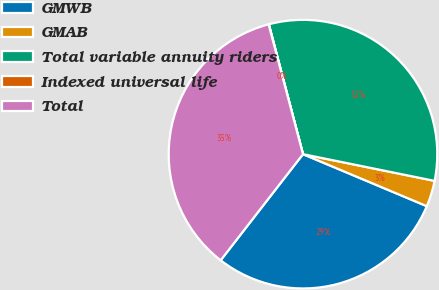Convert chart. <chart><loc_0><loc_0><loc_500><loc_500><pie_chart><fcel>GMWB<fcel>GMAB<fcel>Total variable annuity riders<fcel>Indexed universal life<fcel>Total<nl><fcel>29.17%<fcel>3.14%<fcel>32.28%<fcel>0.03%<fcel>35.38%<nl></chart> 